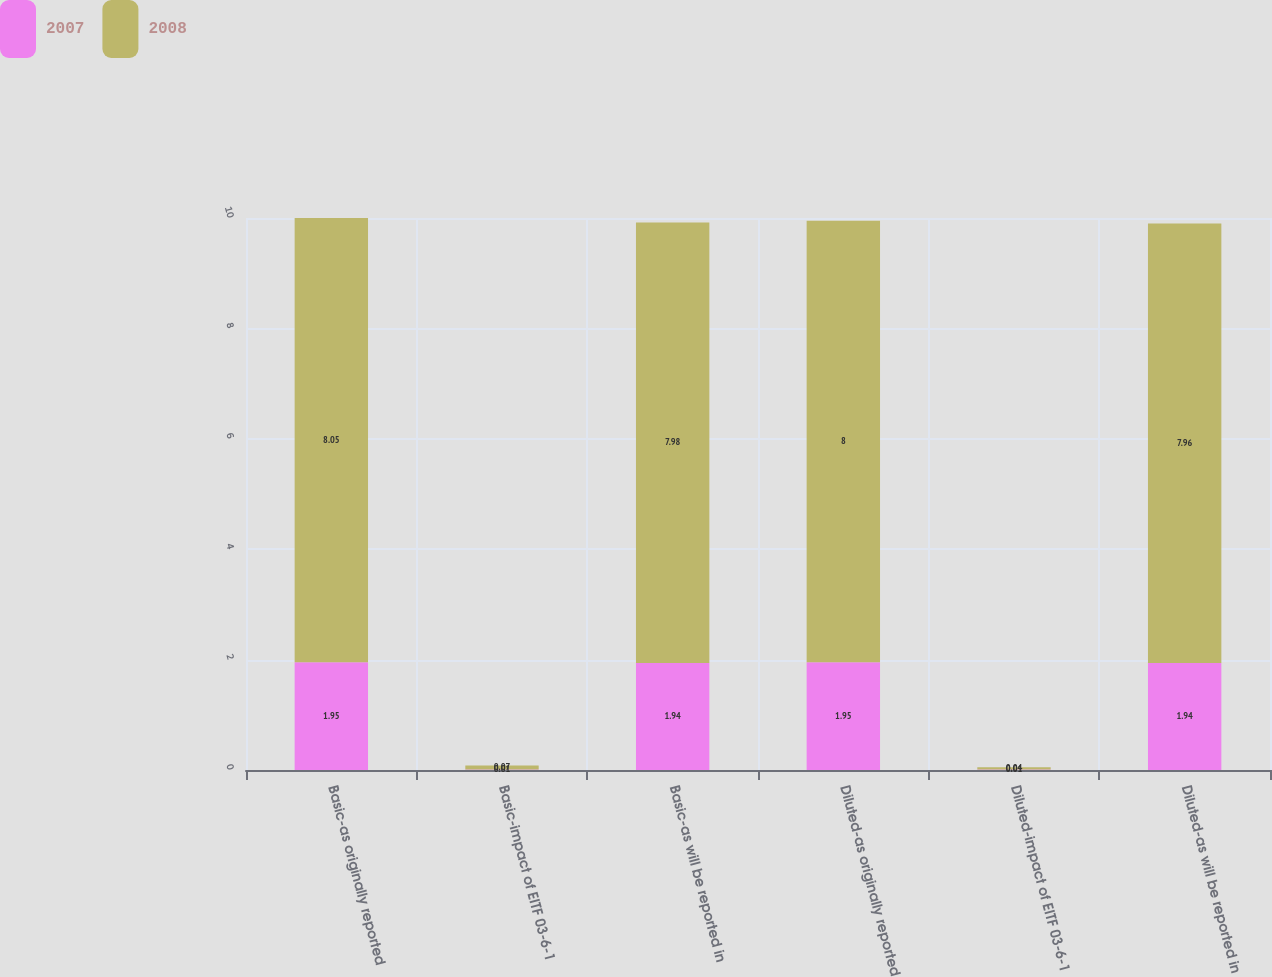Convert chart. <chart><loc_0><loc_0><loc_500><loc_500><stacked_bar_chart><ecel><fcel>Basic-as originally reported<fcel>Basic-impact of EITF 03-6-1<fcel>Basic-as will be reported in<fcel>Diluted-as originally reported<fcel>Diluted-impact of EITF 03-6-1<fcel>Diluted-as will be reported in<nl><fcel>2007<fcel>1.95<fcel>0.01<fcel>1.94<fcel>1.95<fcel>0.01<fcel>1.94<nl><fcel>2008<fcel>8.05<fcel>0.07<fcel>7.98<fcel>8<fcel>0.04<fcel>7.96<nl></chart> 